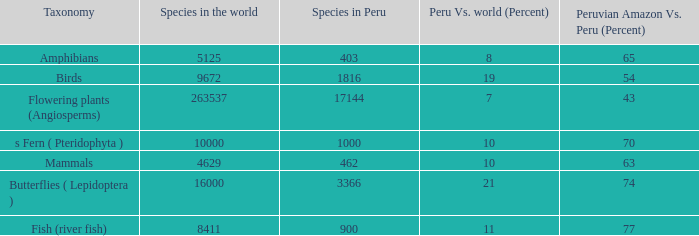What's the total number of species in the peruvian amazon with 8411 species in the world  1.0. Could you parse the entire table as a dict? {'header': ['Taxonomy', 'Species in the world', 'Species in Peru', 'Peru Vs. world (Percent)', 'Peruvian Amazon Vs. Peru (Percent)'], 'rows': [['Amphibians', '5125', '403', '8', '65'], ['Birds', '9672', '1816', '19', '54'], ['Flowering plants (Angiosperms)', '263537', '17144', '7', '43'], ['s Fern ( Pteridophyta )', '10000', '1000', '10', '70'], ['Mammals', '4629', '462', '10', '63'], ['Butterflies ( Lepidoptera )', '16000', '3366', '21', '74'], ['Fish (river fish)', '8411', '900', '11', '77']]} 